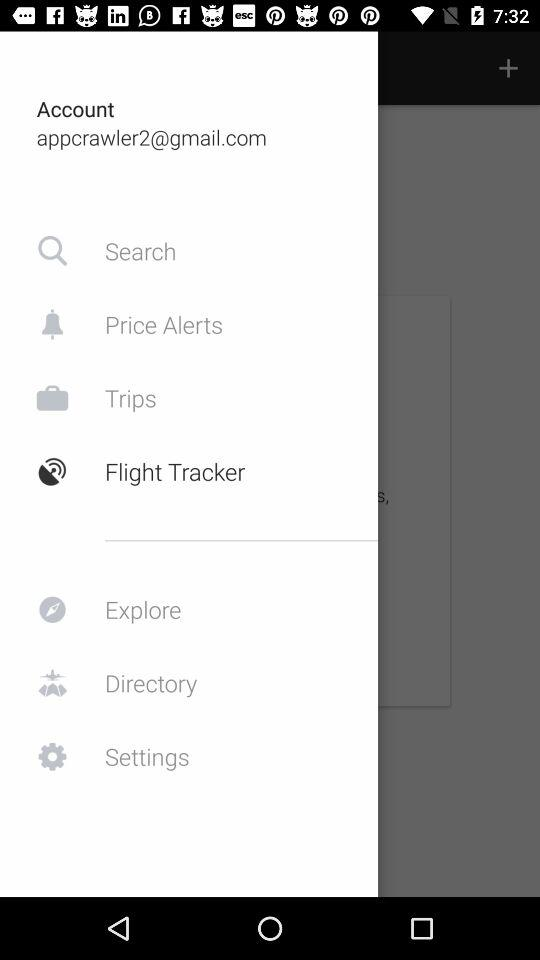What is the email address? The email address is appcrawler2@gmail.com. 